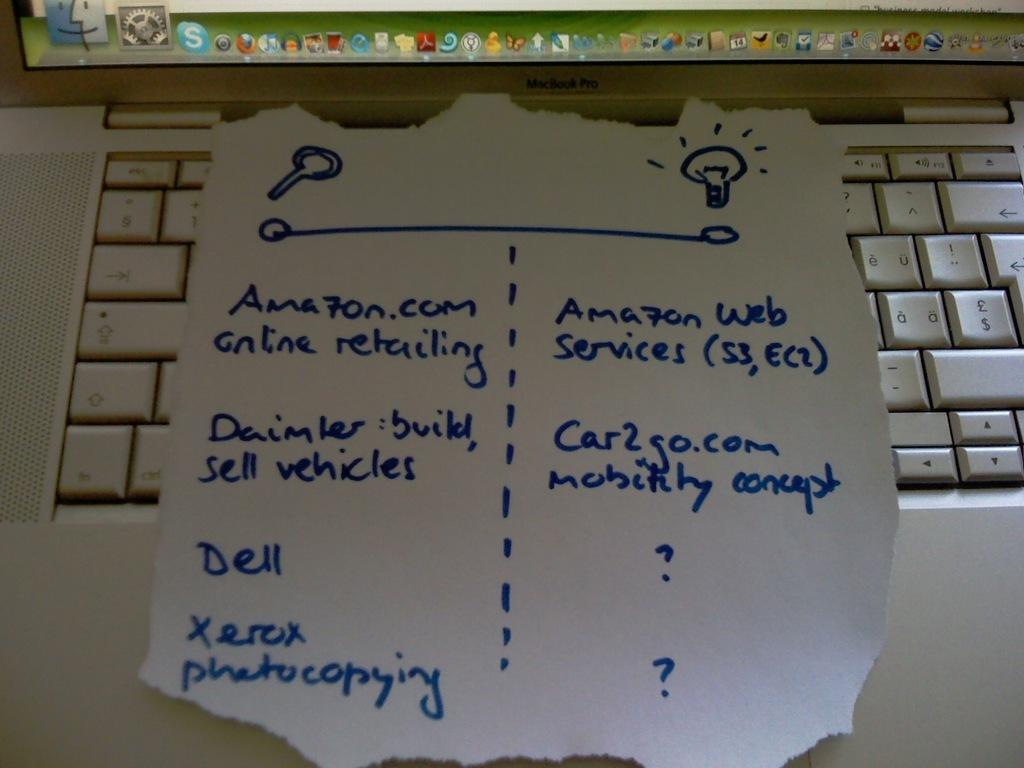<image>
Offer a succinct explanation of the picture presented. a note paper on top of a keyboard that says 'amazon.com online retailing' on it 